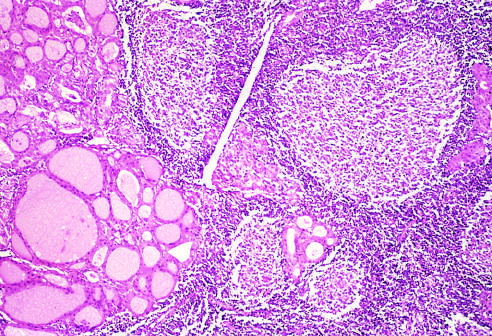re typical pattern of neutrophils emanating from a crypt seen?
Answer the question using a single word or phrase. No 